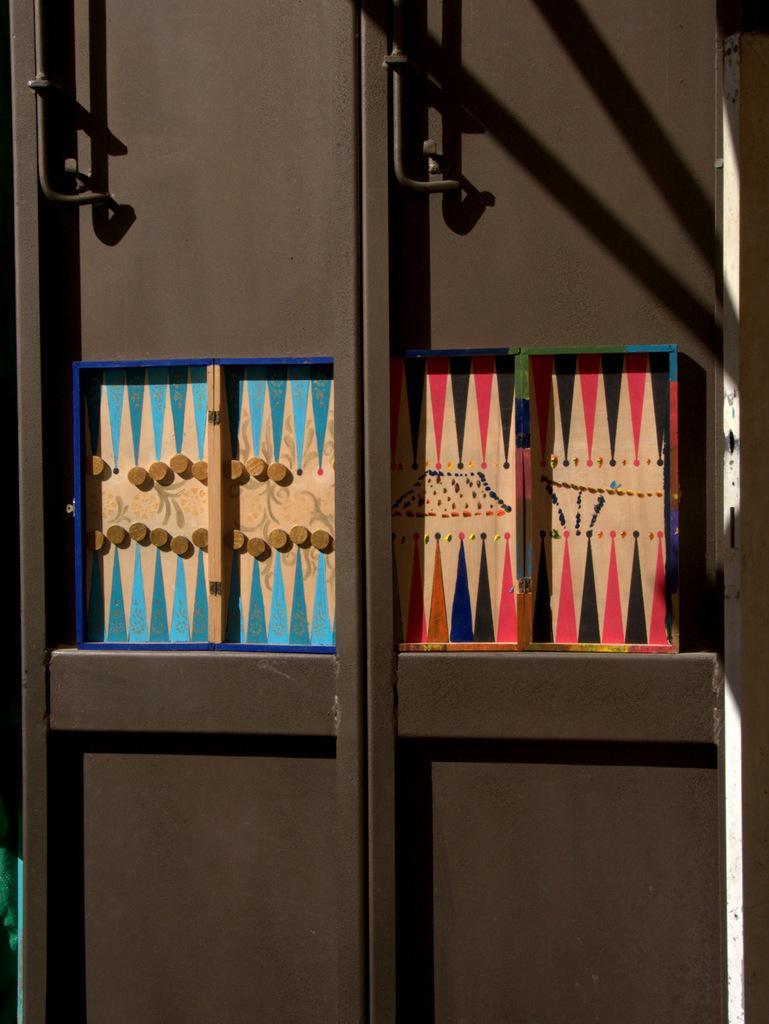In one or two sentences, can you explain what this image depicts? This picture is taken from outside of the door. In this image, on the right side, we can see two wooden boxes which are placed on the door. On the left side, we can also see two wood boxes with some coins which are placed on the door. In the background, we can see a door which is brown in color. 